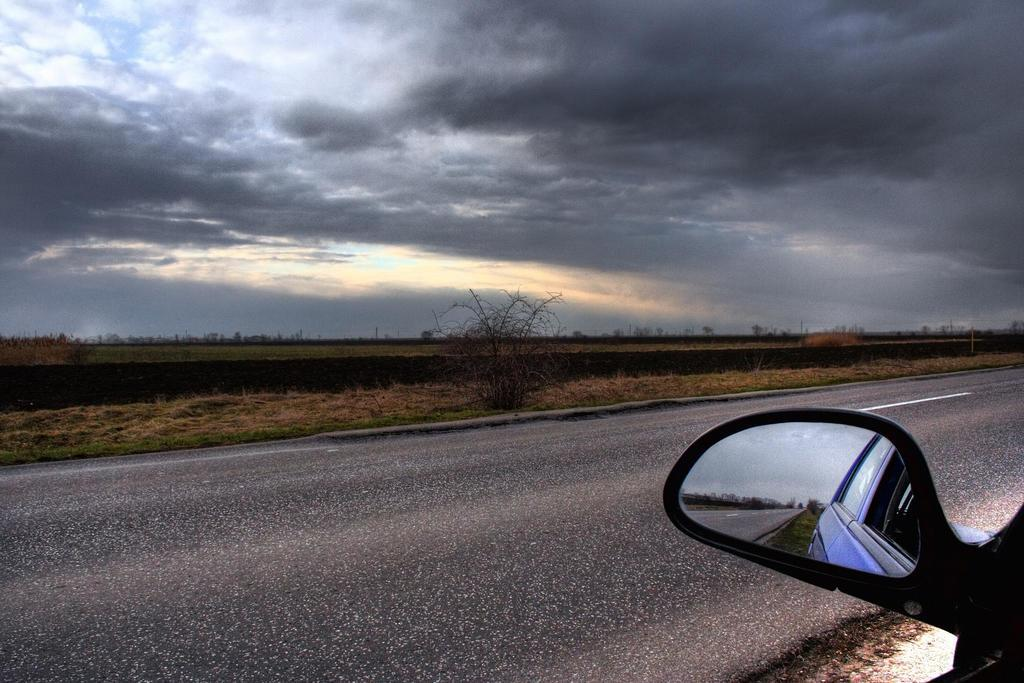What object is present in the image that allows for reflection? There is a side mirror in the image. What does the side mirror reflect in the image? The side mirror reflects a car and a road in the image. What type of natural elements can be seen in the image? There are plants visible in the image. What is visible in the background of the image? The sky is visible in the background of the image. How would you describe the weather based on the appearance of the sky? The sky appears to be cloudy in the image. How many seeds can be seen in the image? There are no seeds present in the image. What things can be seen in the image besides the side mirror? The image only shows a side mirror reflecting a car and a road, plants, and a cloudy sky. There are no other things mentioned in the facts. 